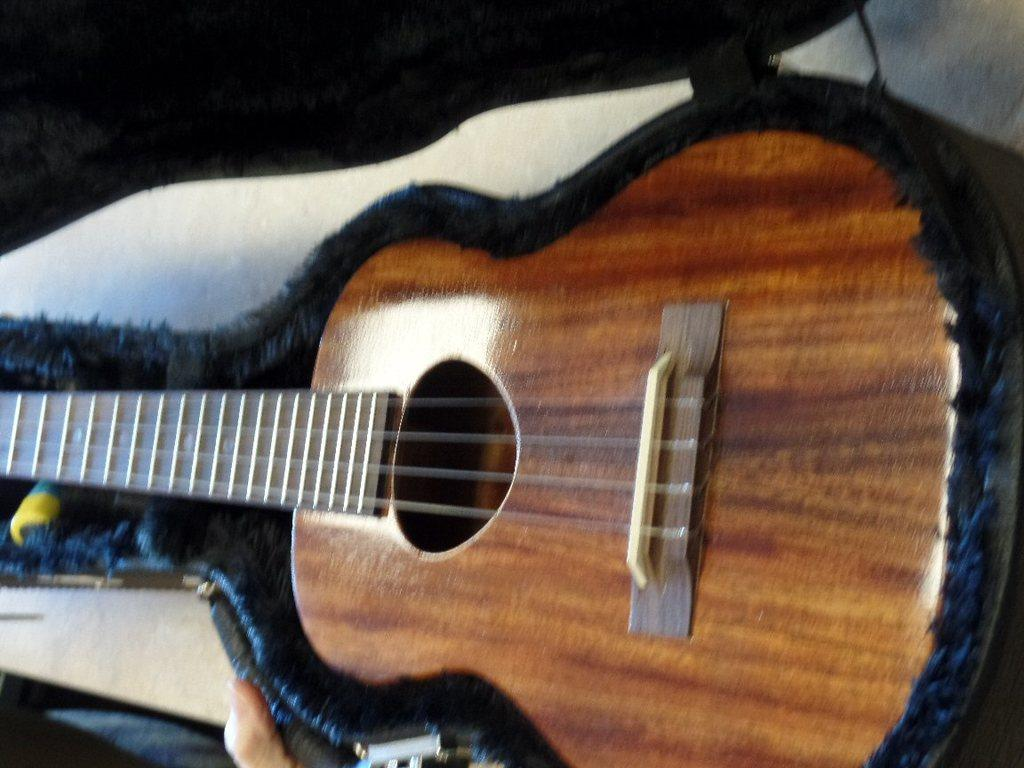What musical instrument is present in the image? There is a guitar in the image. What feature of the guitar is mentioned in the facts? The guitar has strings. How often does the guitar need a haircut in the image? Guitars do not require haircuts, as they are inanimate objects made of wood and metal. 